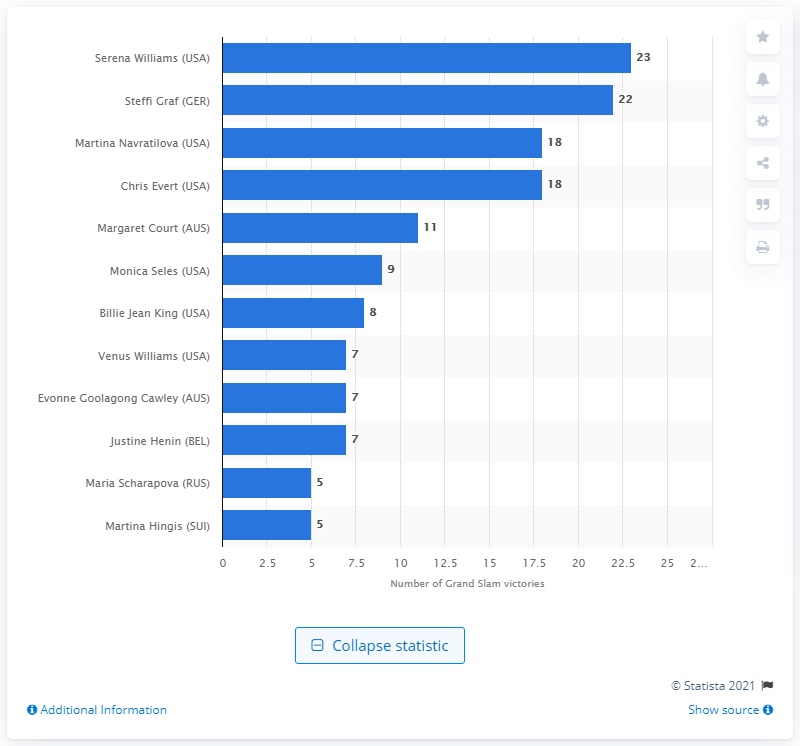Draw attention to some important aspects in this diagram. Serena Williams has won a total of 23 Grand Slam tournament victories, making her one of the most successful tennis players in history. 